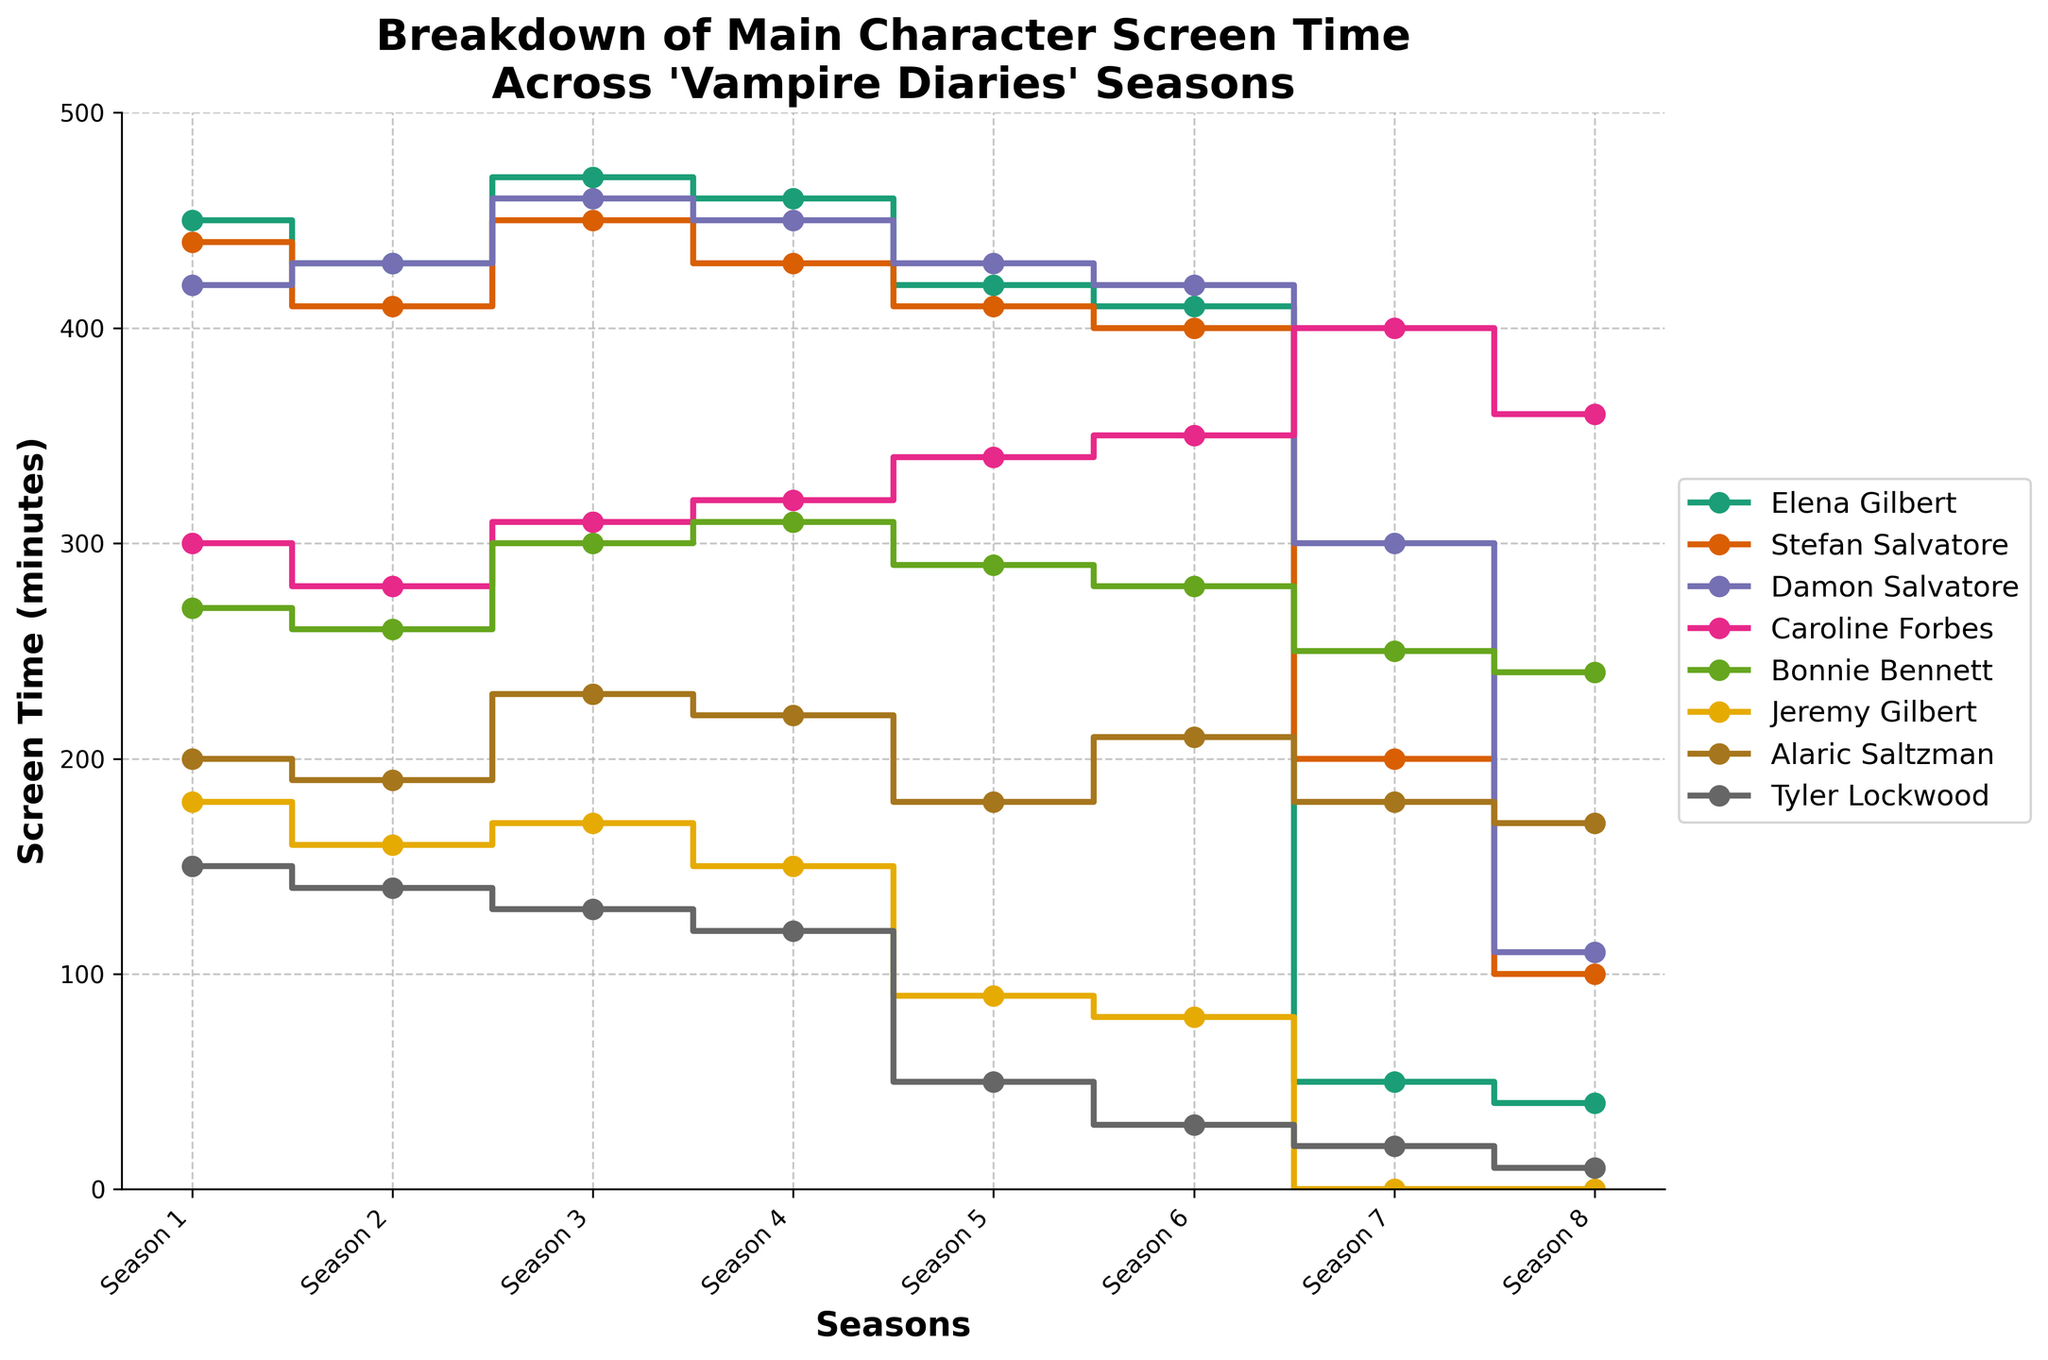What is the title of the figure? The title is usually placed at the top of a figure or chart. In this case, the title indicates what the figure represents.
Answer: "Breakdown of Main Character Screen Time Across 'Vampire Diaries' Seasons" Which character has the highest screen time in Season 1? By looking at the values of screen time for each character in Season 1, identify the highest value.
Answer: Elena Gilbert How did Damon Salvatore's screen time change from Season 1 to Season 8? Check the screen time for Damon Salvatore in Season 1 and compare it to his screen time in Season 8.
Answer: Decreased What is the total screen time of Alaric Saltzman across all seasons? Find the screen time values for Alaric Saltzman in all seasons and sum them up: 200 + 190 + 230 + 220 + 180 + 210 + 180 + 170.
Answer: 1580 minutes How does Caroline Forbes' screen time in Season 8 compare to Bonnie Bennett's screen time in the same season? Both Caroline Forbes and Bonnie Bennett have screen time values for Season 8. Compare these values to see which is higher.
Answer: Caroline Forbes has more screen time Which character sees the most significant drop in screen time from Season 6 to Season 7? Compare the change in screen time between Season 6 and Season 7 for each character. Identify the character with the largest decrease.
Answer: Elena Gilbert What is the average screen time for Stefan Salvatore in Seasons 1, 2, and 3? To find the average, sum the screen times for Stefan Salvatore for these seasons and divide by 3: (440 + 410 + 450) / 3.
Answer: 433.33 minutes In which season does Tyler Lockwood have the lowest screen time? Identify the season with the lowest value for Tyler Lockwood's screen time.
Answer: Season 8 Is there any character whose screen time consistently increases across the seasons? Check the screen time for each character season by season to see if it continuously increases.
Answer: Caroline Forbes What trend can be observed for Jeremy Gilbert's screen time through all the seasons? Look at Jeremy Gilbert's screen time values across all seasons to discern a trend, whether increasing, decreasing, or varied.
Answer: Decreases and then becomes zero by Season 7 